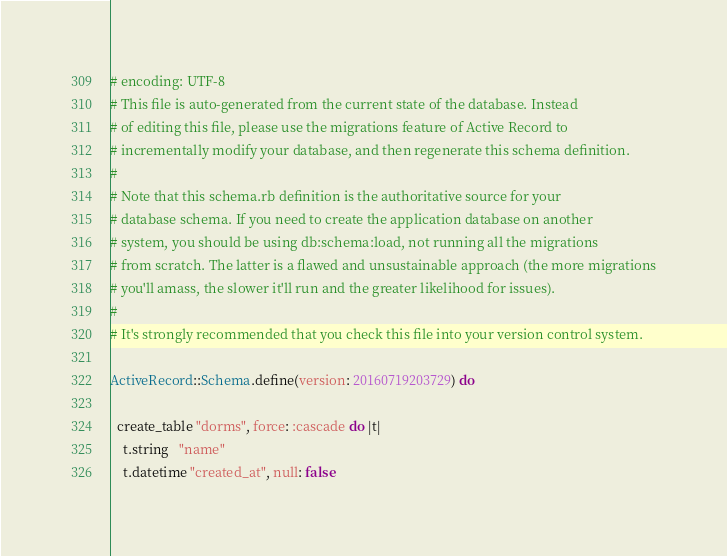Convert code to text. <code><loc_0><loc_0><loc_500><loc_500><_Ruby_># encoding: UTF-8
# This file is auto-generated from the current state of the database. Instead
# of editing this file, please use the migrations feature of Active Record to
# incrementally modify your database, and then regenerate this schema definition.
#
# Note that this schema.rb definition is the authoritative source for your
# database schema. If you need to create the application database on another
# system, you should be using db:schema:load, not running all the migrations
# from scratch. The latter is a flawed and unsustainable approach (the more migrations
# you'll amass, the slower it'll run and the greater likelihood for issues).
#
# It's strongly recommended that you check this file into your version control system.

ActiveRecord::Schema.define(version: 20160719203729) do

  create_table "dorms", force: :cascade do |t|
    t.string   "name"
    t.datetime "created_at", null: false</code> 